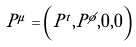Convert formula to latex. <formula><loc_0><loc_0><loc_500><loc_500>P ^ { \mu } = \left ( P ^ { t } , P ^ { \phi } , 0 , 0 \right )</formula> 